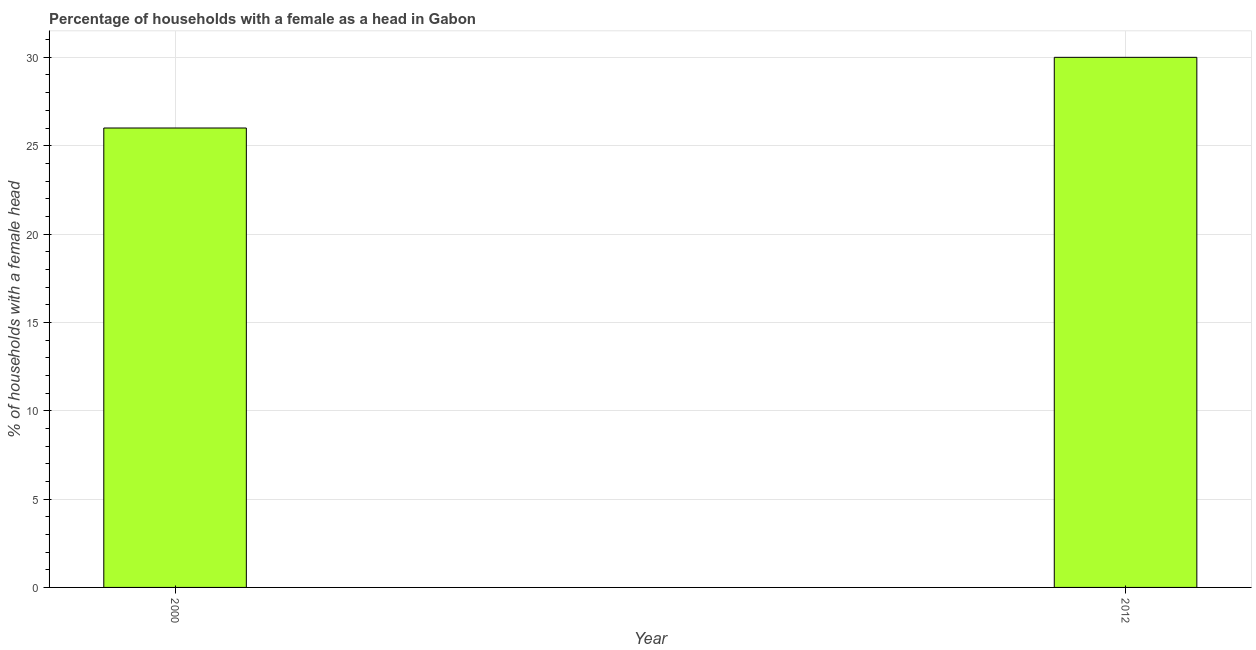Does the graph contain any zero values?
Offer a terse response. No. What is the title of the graph?
Give a very brief answer. Percentage of households with a female as a head in Gabon. What is the label or title of the X-axis?
Offer a terse response. Year. What is the label or title of the Y-axis?
Offer a terse response. % of households with a female head. What is the number of female supervised households in 2012?
Your answer should be very brief. 30. In which year was the number of female supervised households maximum?
Provide a short and direct response. 2012. In which year was the number of female supervised households minimum?
Offer a very short reply. 2000. What is the average number of female supervised households per year?
Provide a short and direct response. 28. What is the ratio of the number of female supervised households in 2000 to that in 2012?
Offer a very short reply. 0.87. Is the number of female supervised households in 2000 less than that in 2012?
Your response must be concise. Yes. Are all the bars in the graph horizontal?
Provide a succinct answer. No. How many years are there in the graph?
Your answer should be very brief. 2. What is the difference between two consecutive major ticks on the Y-axis?
Your answer should be compact. 5. Are the values on the major ticks of Y-axis written in scientific E-notation?
Offer a terse response. No. What is the difference between the % of households with a female head in 2000 and 2012?
Your response must be concise. -4. What is the ratio of the % of households with a female head in 2000 to that in 2012?
Give a very brief answer. 0.87. 